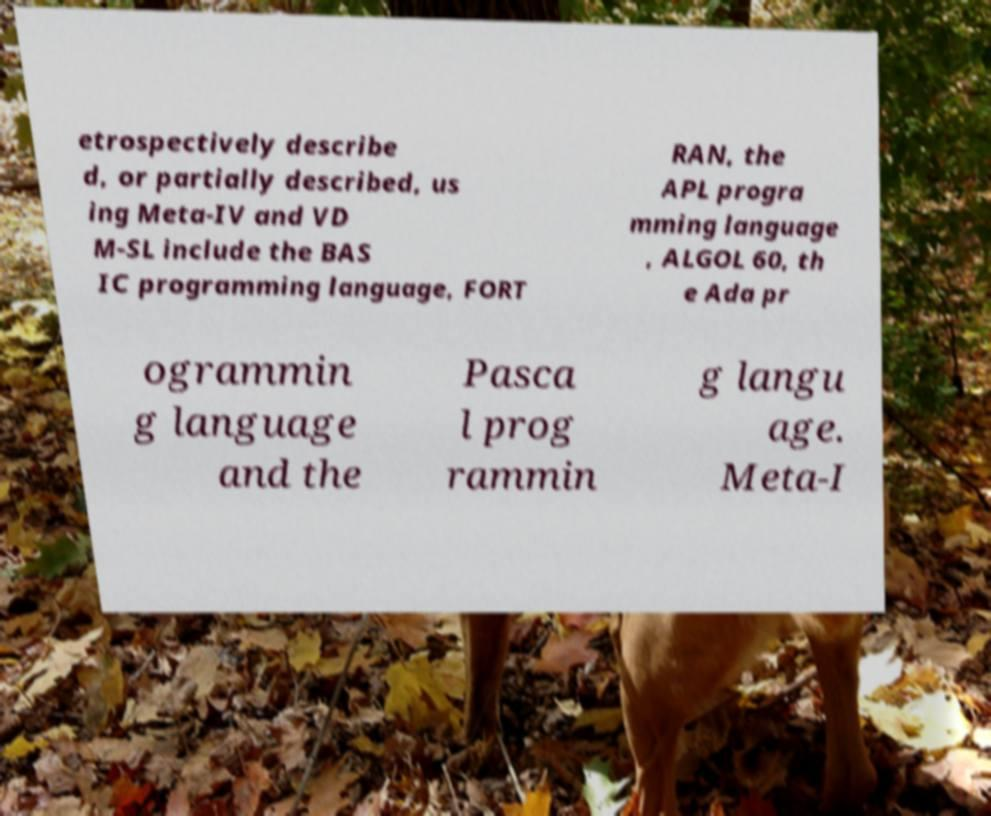There's text embedded in this image that I need extracted. Can you transcribe it verbatim? etrospectively describe d, or partially described, us ing Meta-IV and VD M-SL include the BAS IC programming language, FORT RAN, the APL progra mming language , ALGOL 60, th e Ada pr ogrammin g language and the Pasca l prog rammin g langu age. Meta-I 